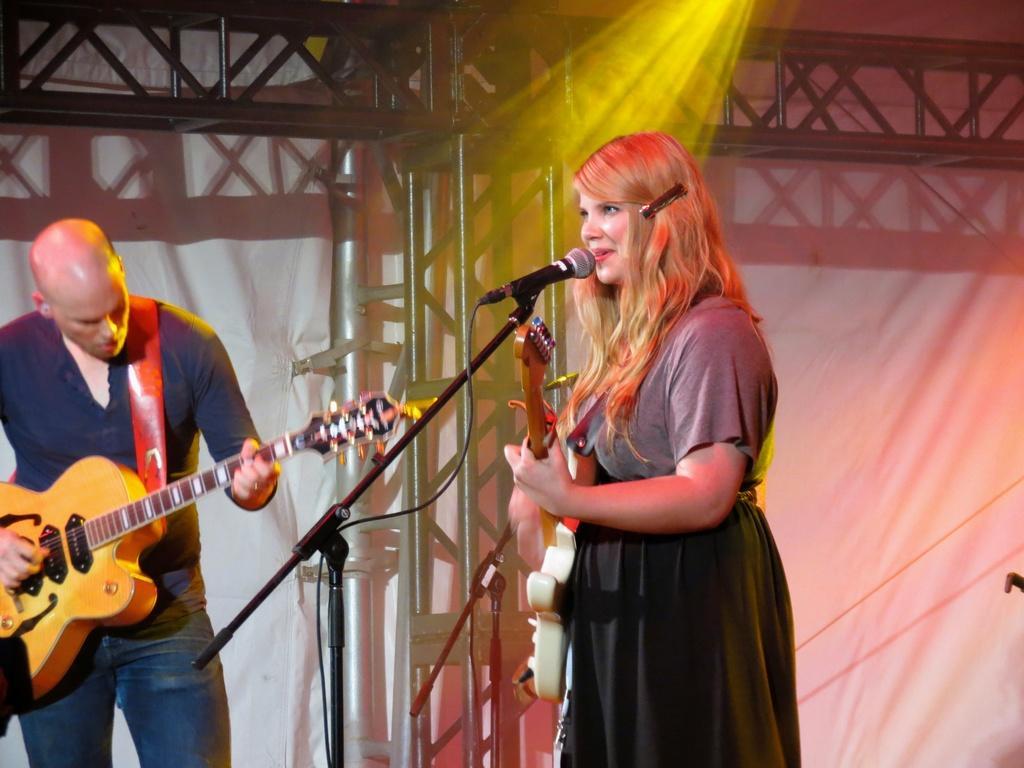How would you summarize this image in a sentence or two? In this picture we can see woman holding guitar in her hands and singing on mic and beside to her man playing guitar and in background we can see pillar, light, wall. 